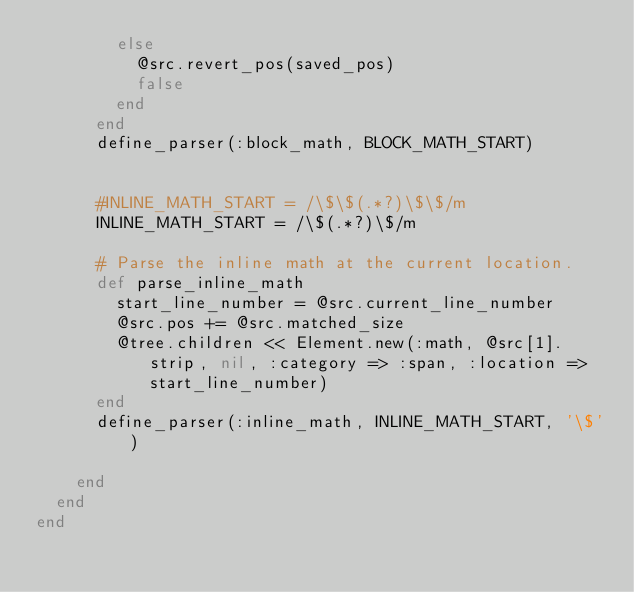Convert code to text. <code><loc_0><loc_0><loc_500><loc_500><_Ruby_>        else
          @src.revert_pos(saved_pos)
          false
        end
      end
      define_parser(:block_math, BLOCK_MATH_START)


      #INLINE_MATH_START = /\$\$(.*?)\$\$/m
      INLINE_MATH_START = /\$(.*?)\$/m

      # Parse the inline math at the current location.
      def parse_inline_math
        start_line_number = @src.current_line_number
        @src.pos += @src.matched_size
        @tree.children << Element.new(:math, @src[1].strip, nil, :category => :span, :location => start_line_number)
      end
      define_parser(:inline_math, INLINE_MATH_START, '\$')

    end
  end
end
</code> 